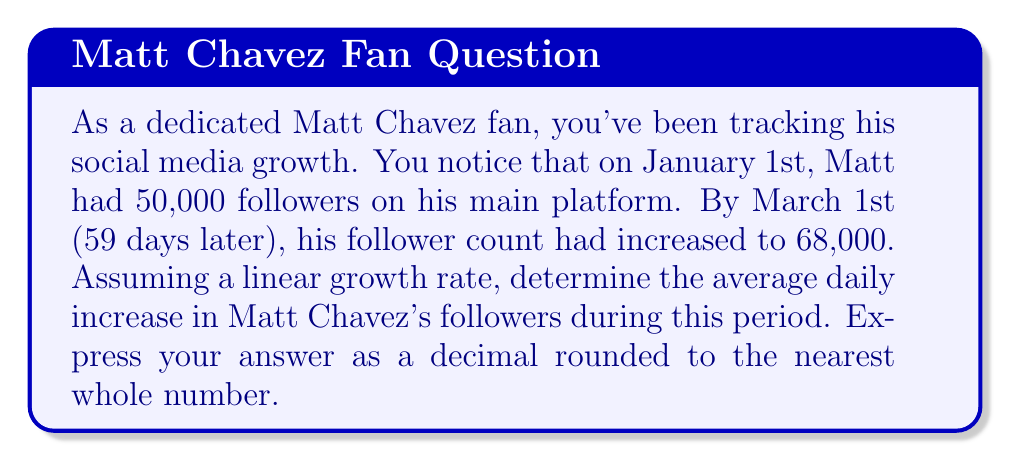Could you help me with this problem? To solve this problem, we need to calculate the rate of change in followers over time. Let's break it down step-by-step:

1. Identify the key information:
   - Initial followers: 50,000 (January 1st)
   - Final followers: 68,000 (March 1st)
   - Time period: 59 days

2. Calculate the total increase in followers:
   $\text{Increase} = \text{Final followers} - \text{Initial followers}$
   $\text{Increase} = 68,000 - 50,000 = 18,000 \text{ followers}$

3. Calculate the rate of change (average daily increase):
   $$\text{Rate of change} = \frac{\text{Change in followers}}{\text{Change in time}}$$
   $$\text{Rate of change} = \frac{18,000 \text{ followers}}{59 \text{ days}}$$

4. Perform the division:
   $$\text{Rate of change} = 305.0847457627119 \text{ followers per day}$$

5. Round to the nearest whole number:
   $$\text{Rate of change} \approx 305 \text{ followers per day}$$
Answer: $305$ followers per day 